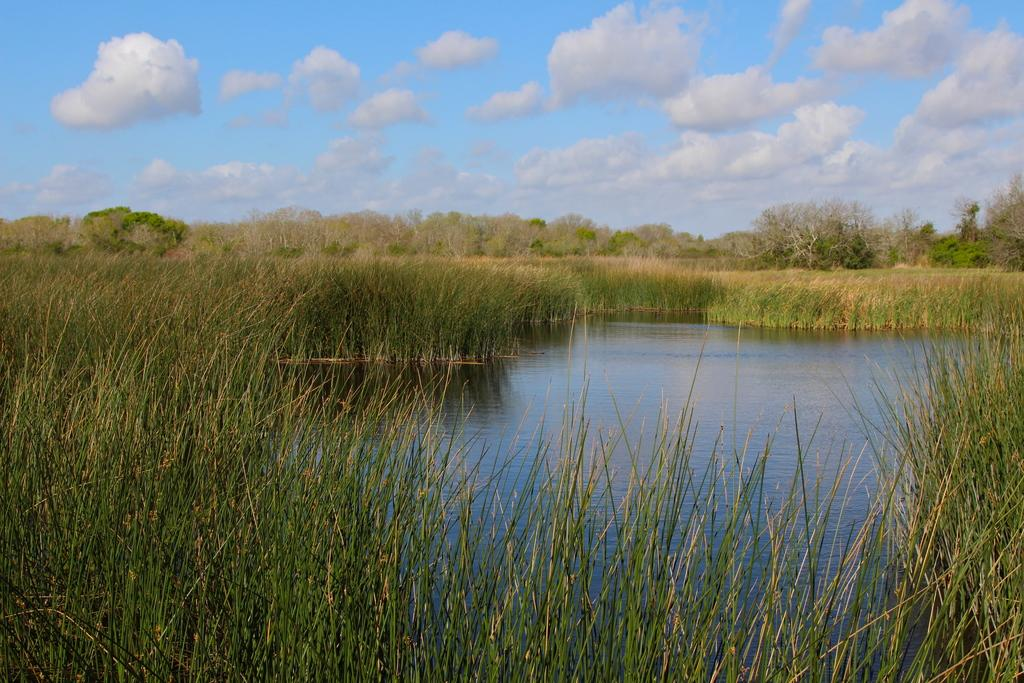What is one of the natural elements visible in the image? Water is visible in the image. What type of vegetation can be seen in the image? There is grass in the image. What is located behind the grass in the image? There is a group of trees behind the grass. What is visible at the top of the image? The sky is visible at the top of the image. Can you see the waves crashing on the shore in the image? There are no waves or shore visible in the image; it features water, grass, trees, and the sky. 